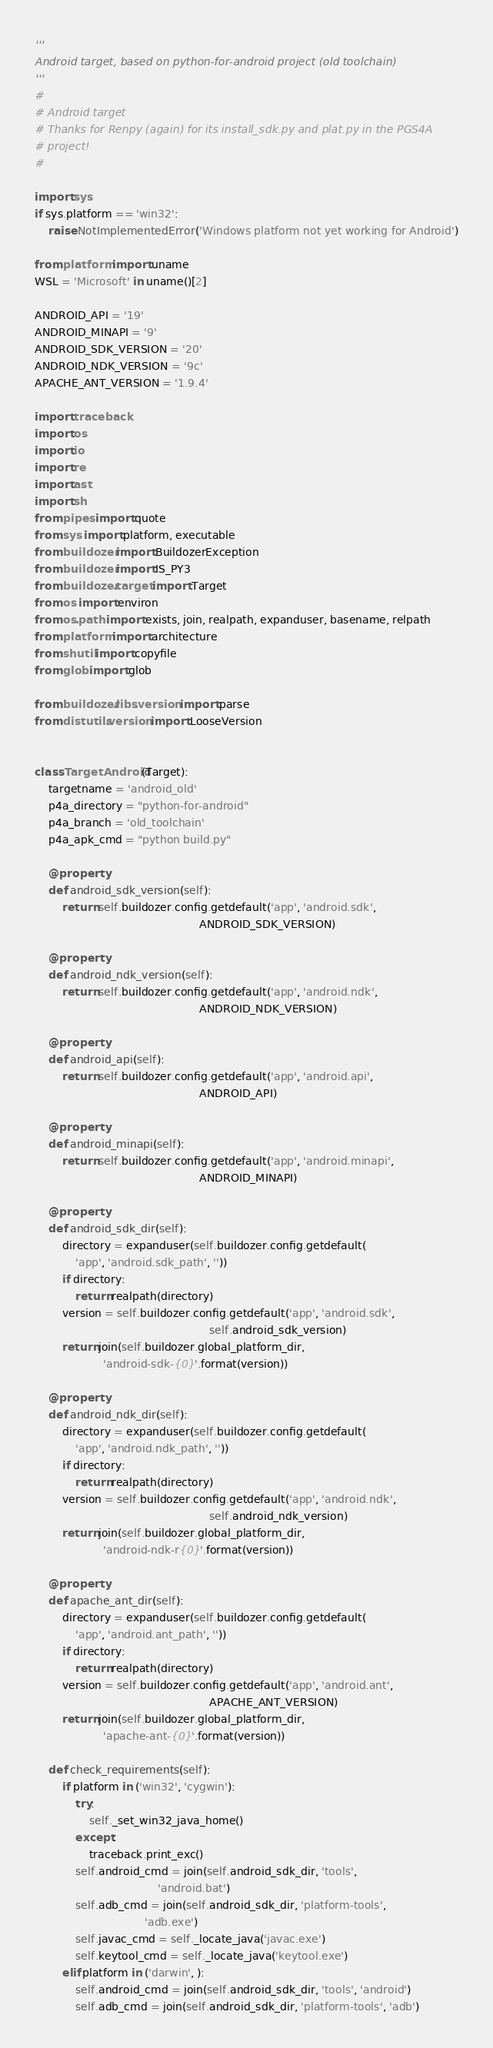Convert code to text. <code><loc_0><loc_0><loc_500><loc_500><_Python_>'''
Android target, based on python-for-android project (old toolchain)
'''
#
# Android target
# Thanks for Renpy (again) for its install_sdk.py and plat.py in the PGS4A
# project!
#

import sys
if sys.platform == 'win32':
    raise NotImplementedError('Windows platform not yet working for Android')

from platform import uname
WSL = 'Microsoft' in uname()[2]

ANDROID_API = '19'
ANDROID_MINAPI = '9'
ANDROID_SDK_VERSION = '20'
ANDROID_NDK_VERSION = '9c'
APACHE_ANT_VERSION = '1.9.4'

import traceback
import os
import io
import re
import ast
import sh
from pipes import quote
from sys import platform, executable
from buildozer import BuildozerException
from buildozer import IS_PY3
from buildozer.target import Target
from os import environ
from os.path import exists, join, realpath, expanduser, basename, relpath
from platform import architecture
from shutil import copyfile
from glob import glob

from buildozer.libs.version import parse
from distutils.version import LooseVersion


class TargetAndroid(Target):
    targetname = 'android_old'
    p4a_directory = "python-for-android"
    p4a_branch = 'old_toolchain'
    p4a_apk_cmd = "python build.py"

    @property
    def android_sdk_version(self):
        return self.buildozer.config.getdefault('app', 'android.sdk',
                                                ANDROID_SDK_VERSION)

    @property
    def android_ndk_version(self):
        return self.buildozer.config.getdefault('app', 'android.ndk',
                                                ANDROID_NDK_VERSION)

    @property
    def android_api(self):
        return self.buildozer.config.getdefault('app', 'android.api',
                                                ANDROID_API)

    @property
    def android_minapi(self):
        return self.buildozer.config.getdefault('app', 'android.minapi',
                                                ANDROID_MINAPI)

    @property
    def android_sdk_dir(self):
        directory = expanduser(self.buildozer.config.getdefault(
            'app', 'android.sdk_path', ''))
        if directory:
            return realpath(directory)
        version = self.buildozer.config.getdefault('app', 'android.sdk',
                                                   self.android_sdk_version)
        return join(self.buildozer.global_platform_dir,
                    'android-sdk-{0}'.format(version))

    @property
    def android_ndk_dir(self):
        directory = expanduser(self.buildozer.config.getdefault(
            'app', 'android.ndk_path', ''))
        if directory:
            return realpath(directory)
        version = self.buildozer.config.getdefault('app', 'android.ndk',
                                                   self.android_ndk_version)
        return join(self.buildozer.global_platform_dir,
                    'android-ndk-r{0}'.format(version))

    @property
    def apache_ant_dir(self):
        directory = expanduser(self.buildozer.config.getdefault(
            'app', 'android.ant_path', ''))
        if directory:
            return realpath(directory)
        version = self.buildozer.config.getdefault('app', 'android.ant',
                                                   APACHE_ANT_VERSION)
        return join(self.buildozer.global_platform_dir,
                    'apache-ant-{0}'.format(version))

    def check_requirements(self):
        if platform in ('win32', 'cygwin'):
            try:
                self._set_win32_java_home()
            except:
                traceback.print_exc()
            self.android_cmd = join(self.android_sdk_dir, 'tools',
                                    'android.bat')
            self.adb_cmd = join(self.android_sdk_dir, 'platform-tools',
                                'adb.exe')
            self.javac_cmd = self._locate_java('javac.exe')
            self.keytool_cmd = self._locate_java('keytool.exe')
        elif platform in ('darwin', ):
            self.android_cmd = join(self.android_sdk_dir, 'tools', 'android')
            self.adb_cmd = join(self.android_sdk_dir, 'platform-tools', 'adb')</code> 